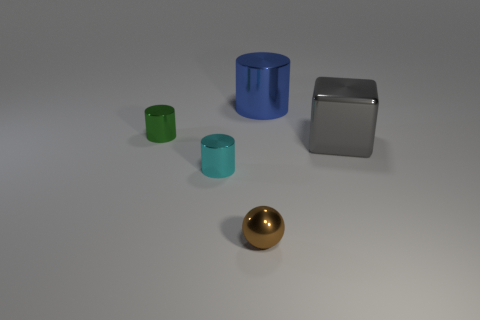Add 3 brown blocks. How many objects exist? 8 Subtract all cylinders. How many objects are left? 2 Subtract 0 purple spheres. How many objects are left? 5 Subtract all tiny green shiny cylinders. Subtract all small red metallic cubes. How many objects are left? 4 Add 4 cyan metal things. How many cyan metal things are left? 5 Add 3 cylinders. How many cylinders exist? 6 